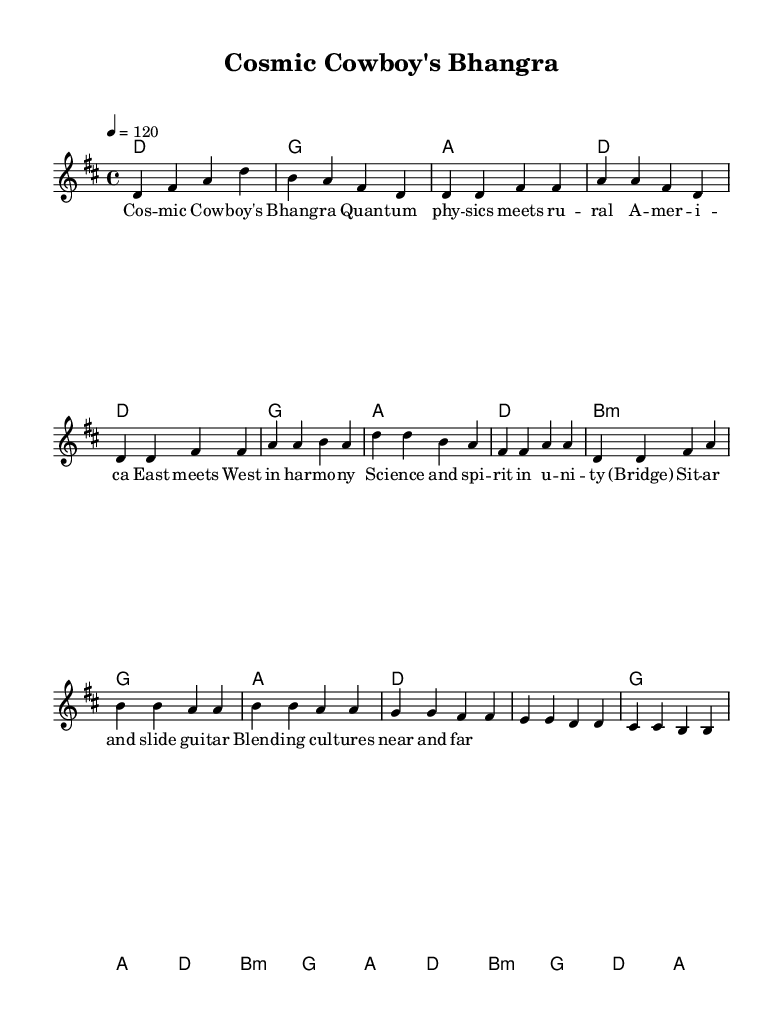What is the key signature of this music? The key signature indicates D major, which has two sharps (F# and C#). This can be inferred from the key indicated at the beginning of the sheet music.
Answer: D major What is the time signature of this piece? The time signature shown is 4/4, meaning there are four beats in each measure, and a quarter note gets one beat. This is explicitly stated at the beginning of the music.
Answer: 4/4 What is the tempo marking? The tempo is indicated as 120 beats per minute, as denoted by the "4 = 120" marking which tells the musician the speed of the piece.
Answer: 120 How many measures are in the chorus section? The chorus consists of four measures as inferred from the music structure: two measures for the first line and two for the next line.
Answer: 4 What musical instruments are likely featured based on the structure? Considering the presence of sitar and slide guitar in the lyrics, it suggests the inclusion of traditional Indian and American instruments, indicating a fusion style.
Answer: Sitar and slide guitar What type of chord is used in the bridge section? The bridge begins with a B minor chord, as shown in the chord names written above the melody, signaling a shift in harmony.
Answer: B minor What theme does this song combine with traditional Americana? The song merges quantum physics concepts with rural Americana themes, as suggested by the lyrics which highlight the fusion of science and folk culture.
Answer: Quantum physics and rural Americana 